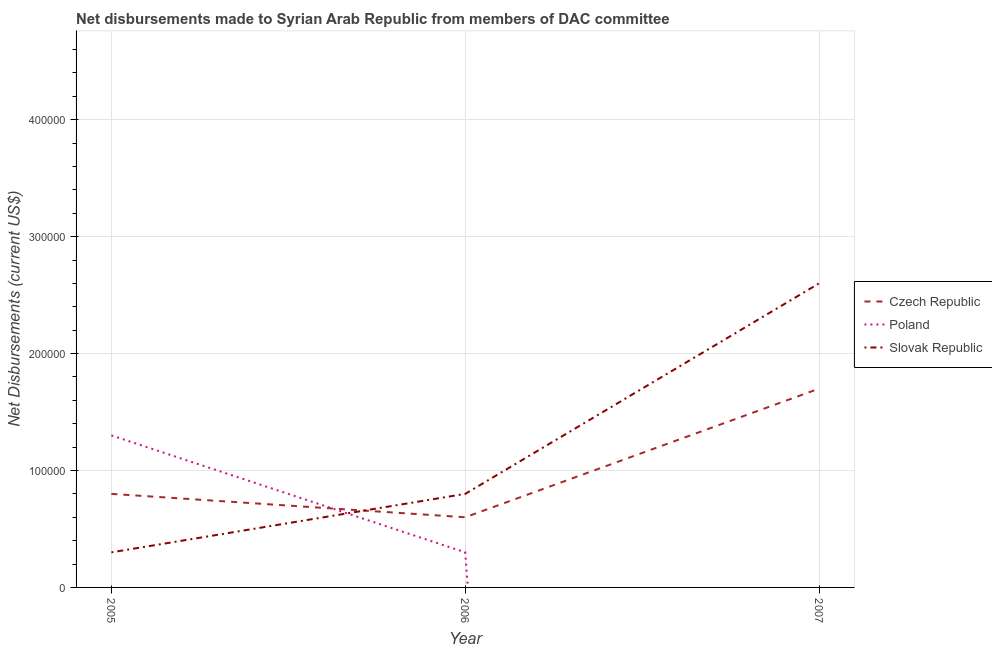Does the line corresponding to net disbursements made by poland intersect with the line corresponding to net disbursements made by czech republic?
Provide a short and direct response. Yes. Is the number of lines equal to the number of legend labels?
Provide a short and direct response. No. What is the net disbursements made by czech republic in 2005?
Make the answer very short. 8.00e+04. Across all years, what is the maximum net disbursements made by poland?
Make the answer very short. 1.30e+05. Across all years, what is the minimum net disbursements made by czech republic?
Provide a short and direct response. 6.00e+04. What is the total net disbursements made by poland in the graph?
Provide a succinct answer. 1.60e+05. What is the difference between the net disbursements made by slovak republic in 2005 and that in 2006?
Keep it short and to the point. -5.00e+04. What is the difference between the net disbursements made by poland in 2006 and the net disbursements made by czech republic in 2005?
Your response must be concise. -5.00e+04. What is the average net disbursements made by slovak republic per year?
Provide a short and direct response. 1.23e+05. In the year 2006, what is the difference between the net disbursements made by czech republic and net disbursements made by slovak republic?
Ensure brevity in your answer.  -2.00e+04. What is the ratio of the net disbursements made by czech republic in 2005 to that in 2006?
Provide a short and direct response. 1.33. Is the net disbursements made by czech republic in 2006 less than that in 2007?
Offer a terse response. Yes. Is the difference between the net disbursements made by poland in 2005 and 2006 greater than the difference between the net disbursements made by czech republic in 2005 and 2006?
Your answer should be compact. Yes. What is the difference between the highest and the second highest net disbursements made by slovak republic?
Your answer should be very brief. 1.80e+05. What is the difference between the highest and the lowest net disbursements made by czech republic?
Provide a succinct answer. 1.10e+05. Is it the case that in every year, the sum of the net disbursements made by czech republic and net disbursements made by poland is greater than the net disbursements made by slovak republic?
Offer a terse response. No. How many lines are there?
Your response must be concise. 3. What is the difference between two consecutive major ticks on the Y-axis?
Your response must be concise. 1.00e+05. Are the values on the major ticks of Y-axis written in scientific E-notation?
Provide a succinct answer. No. Does the graph contain grids?
Offer a very short reply. Yes. Where does the legend appear in the graph?
Offer a terse response. Center right. What is the title of the graph?
Ensure brevity in your answer.  Net disbursements made to Syrian Arab Republic from members of DAC committee. Does "Social Protection" appear as one of the legend labels in the graph?
Your answer should be very brief. No. What is the label or title of the Y-axis?
Provide a short and direct response. Net Disbursements (current US$). What is the Net Disbursements (current US$) of Czech Republic in 2005?
Ensure brevity in your answer.  8.00e+04. What is the Net Disbursements (current US$) in Slovak Republic in 2006?
Keep it short and to the point. 8.00e+04. What is the Net Disbursements (current US$) of Czech Republic in 2007?
Give a very brief answer. 1.70e+05. What is the Net Disbursements (current US$) of Poland in 2007?
Keep it short and to the point. 0. What is the Net Disbursements (current US$) of Slovak Republic in 2007?
Provide a short and direct response. 2.60e+05. Across all years, what is the maximum Net Disbursements (current US$) of Poland?
Offer a terse response. 1.30e+05. Across all years, what is the minimum Net Disbursements (current US$) in Czech Republic?
Ensure brevity in your answer.  6.00e+04. Across all years, what is the minimum Net Disbursements (current US$) in Slovak Republic?
Give a very brief answer. 3.00e+04. What is the total Net Disbursements (current US$) of Slovak Republic in the graph?
Offer a terse response. 3.70e+05. What is the difference between the Net Disbursements (current US$) in Czech Republic in 2005 and that in 2006?
Ensure brevity in your answer.  2.00e+04. What is the difference between the Net Disbursements (current US$) of Poland in 2005 and that in 2006?
Provide a succinct answer. 1.00e+05. What is the difference between the Net Disbursements (current US$) of Czech Republic in 2005 and the Net Disbursements (current US$) of Poland in 2006?
Offer a very short reply. 5.00e+04. What is the difference between the Net Disbursements (current US$) in Poland in 2005 and the Net Disbursements (current US$) in Slovak Republic in 2007?
Offer a terse response. -1.30e+05. What is the difference between the Net Disbursements (current US$) in Czech Republic in 2006 and the Net Disbursements (current US$) in Slovak Republic in 2007?
Provide a short and direct response. -2.00e+05. What is the average Net Disbursements (current US$) of Czech Republic per year?
Make the answer very short. 1.03e+05. What is the average Net Disbursements (current US$) of Poland per year?
Offer a very short reply. 5.33e+04. What is the average Net Disbursements (current US$) of Slovak Republic per year?
Ensure brevity in your answer.  1.23e+05. In the year 2005, what is the difference between the Net Disbursements (current US$) of Poland and Net Disbursements (current US$) of Slovak Republic?
Keep it short and to the point. 1.00e+05. In the year 2006, what is the difference between the Net Disbursements (current US$) of Czech Republic and Net Disbursements (current US$) of Poland?
Your response must be concise. 3.00e+04. In the year 2006, what is the difference between the Net Disbursements (current US$) in Poland and Net Disbursements (current US$) in Slovak Republic?
Provide a short and direct response. -5.00e+04. What is the ratio of the Net Disbursements (current US$) in Poland in 2005 to that in 2006?
Offer a terse response. 4.33. What is the ratio of the Net Disbursements (current US$) of Slovak Republic in 2005 to that in 2006?
Offer a very short reply. 0.38. What is the ratio of the Net Disbursements (current US$) in Czech Republic in 2005 to that in 2007?
Your response must be concise. 0.47. What is the ratio of the Net Disbursements (current US$) in Slovak Republic in 2005 to that in 2007?
Offer a very short reply. 0.12. What is the ratio of the Net Disbursements (current US$) of Czech Republic in 2006 to that in 2007?
Your response must be concise. 0.35. What is the ratio of the Net Disbursements (current US$) of Slovak Republic in 2006 to that in 2007?
Your answer should be very brief. 0.31. What is the difference between the highest and the second highest Net Disbursements (current US$) in Czech Republic?
Your answer should be compact. 9.00e+04. What is the difference between the highest and the lowest Net Disbursements (current US$) in Poland?
Your response must be concise. 1.30e+05. What is the difference between the highest and the lowest Net Disbursements (current US$) of Slovak Republic?
Keep it short and to the point. 2.30e+05. 